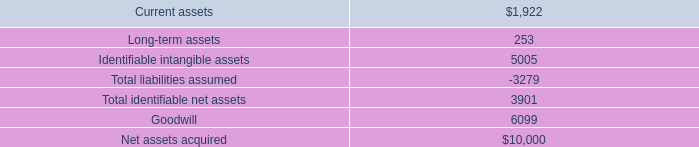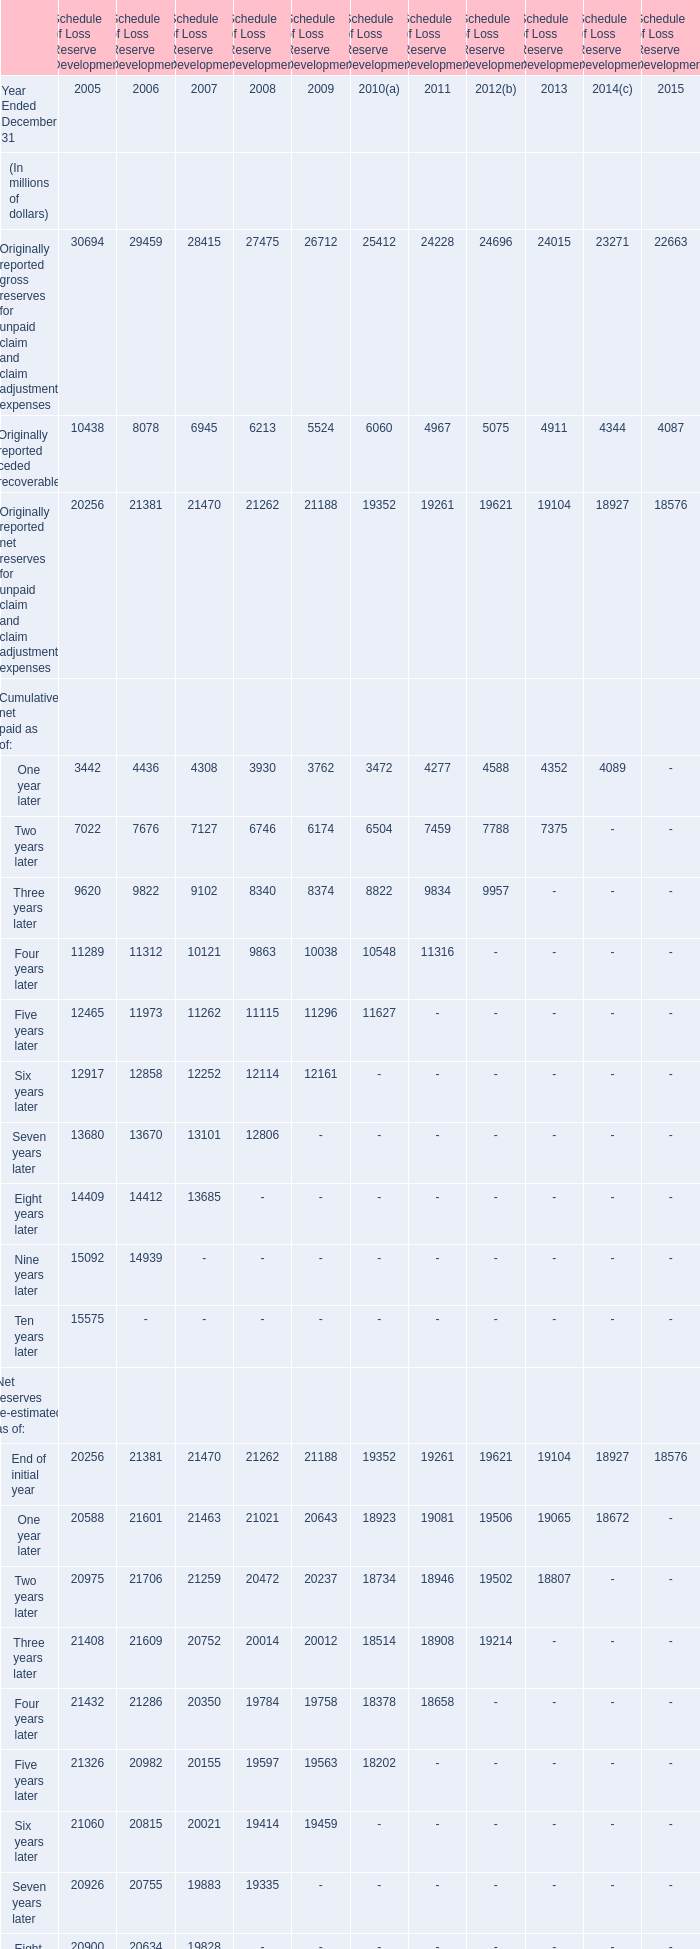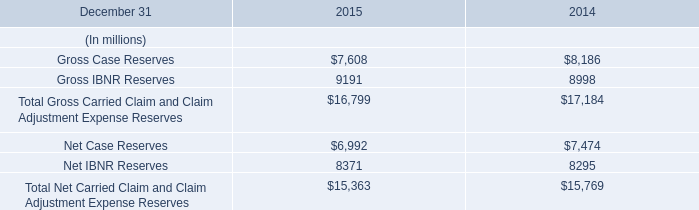When does the amount for originally reported ceded recoverable reach the largest value? 
Answer: 2005. 